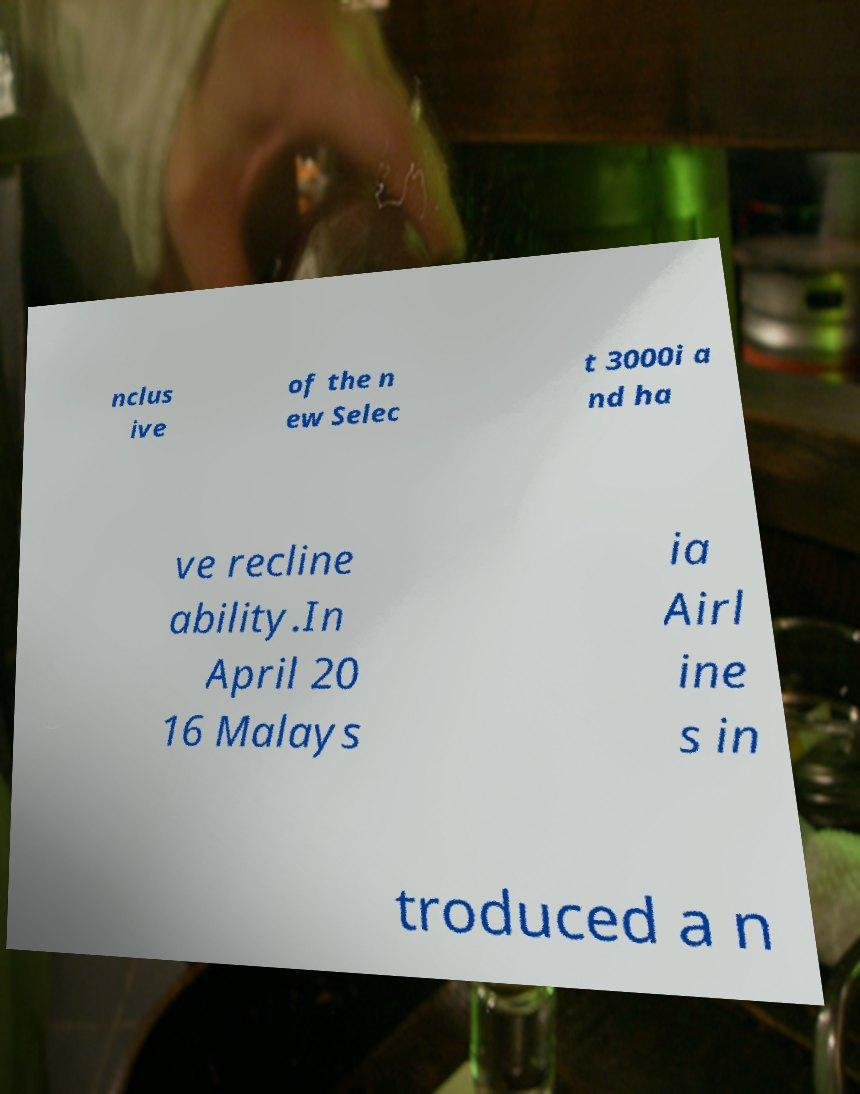Please read and relay the text visible in this image. What does it say? nclus ive of the n ew Selec t 3000i a nd ha ve recline ability.In April 20 16 Malays ia Airl ine s in troduced a n 